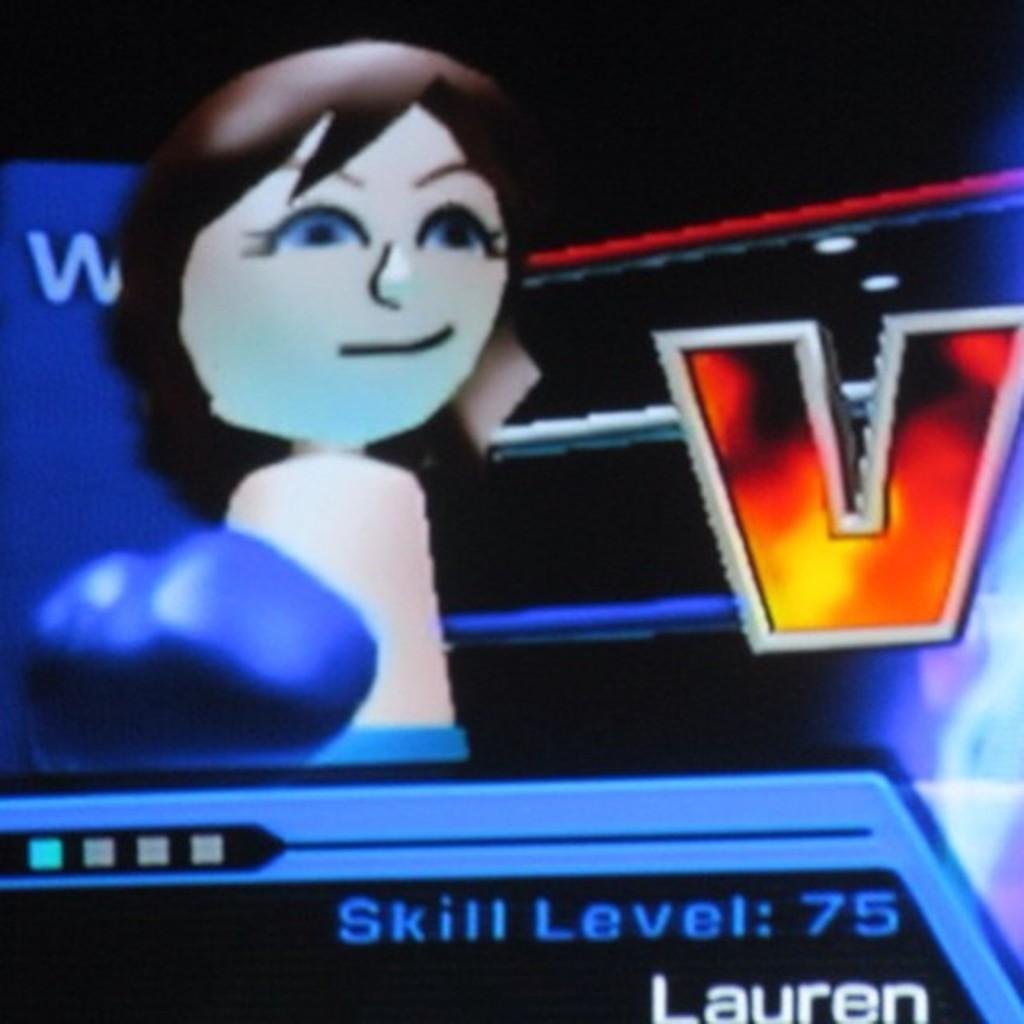What type of image is depicted in the picture? There is a cartoon image of a girl in the picture. What other objects can be seen in the picture? There is a glove and rods in the picture. Is there any text present in the image? Yes, there is some text in the picture. How would you describe the background of the image? The background of the image is dark. What type of stocking is the mother wearing in the image? There is no mother or stocking present in the image; it features a cartoon image of a girl, a glove, rods, text, and a dark background. 